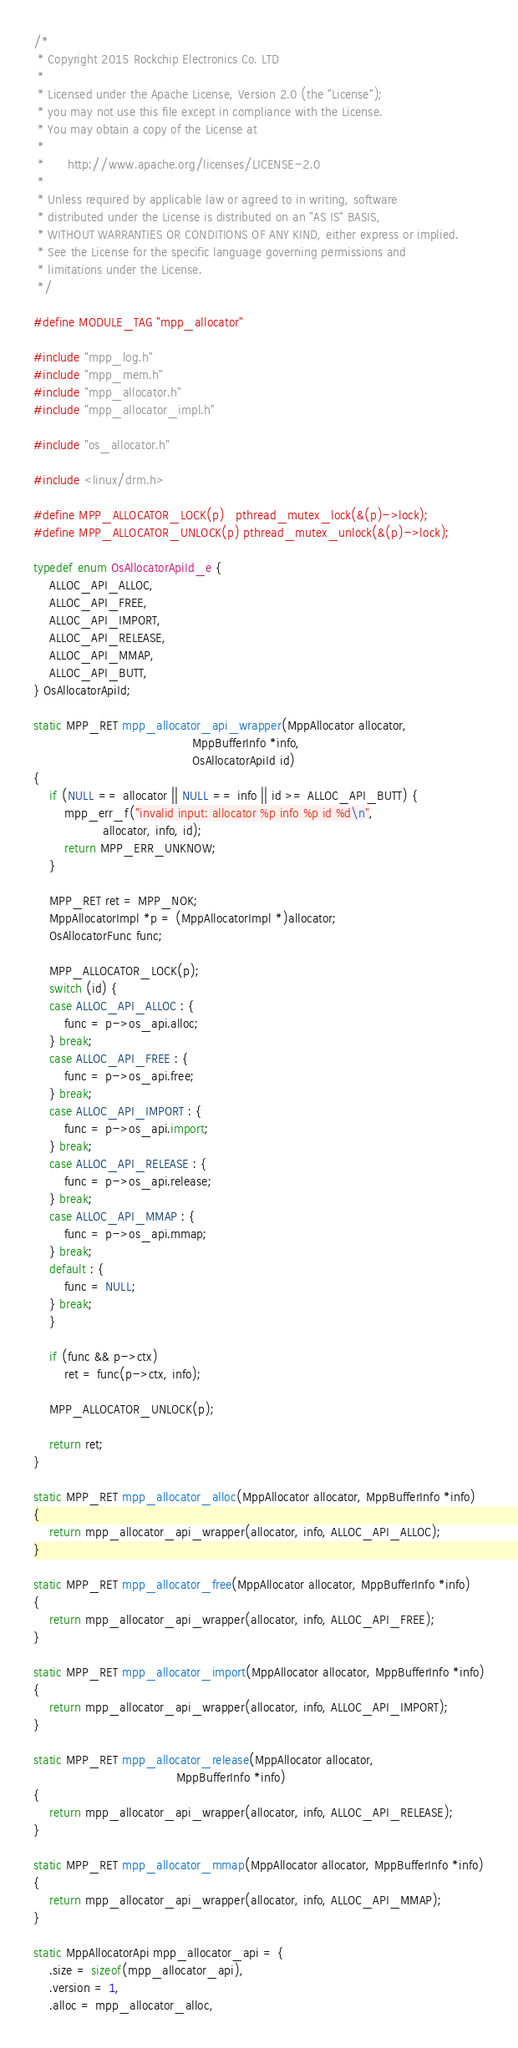<code> <loc_0><loc_0><loc_500><loc_500><_C++_>/*
 * Copyright 2015 Rockchip Electronics Co. LTD
 *
 * Licensed under the Apache License, Version 2.0 (the "License");
 * you may not use this file except in compliance with the License.
 * You may obtain a copy of the License at
 *
 *      http://www.apache.org/licenses/LICENSE-2.0
 *
 * Unless required by applicable law or agreed to in writing, software
 * distributed under the License is distributed on an "AS IS" BASIS,
 * WITHOUT WARRANTIES OR CONDITIONS OF ANY KIND, either express or implied.
 * See the License for the specific language governing permissions and
 * limitations under the License.
 */

#define MODULE_TAG "mpp_allocator"

#include "mpp_log.h"
#include "mpp_mem.h"
#include "mpp_allocator.h"
#include "mpp_allocator_impl.h"

#include "os_allocator.h"

#include <linux/drm.h>

#define MPP_ALLOCATOR_LOCK(p)   pthread_mutex_lock(&(p)->lock);
#define MPP_ALLOCATOR_UNLOCK(p) pthread_mutex_unlock(&(p)->lock);

typedef enum OsAllocatorApiId_e {
    ALLOC_API_ALLOC,
    ALLOC_API_FREE,
    ALLOC_API_IMPORT,
    ALLOC_API_RELEASE,
    ALLOC_API_MMAP,
    ALLOC_API_BUTT,
} OsAllocatorApiId;

static MPP_RET mpp_allocator_api_wrapper(MppAllocator allocator,
                                         MppBufferInfo *info,
                                         OsAllocatorApiId id)
{
    if (NULL == allocator || NULL == info || id >= ALLOC_API_BUTT) {
        mpp_err_f("invalid input: allocator %p info %p id %d\n",
                  allocator, info, id);
        return MPP_ERR_UNKNOW;
    }

    MPP_RET ret = MPP_NOK;
    MppAllocatorImpl *p = (MppAllocatorImpl *)allocator;
    OsAllocatorFunc func;

    MPP_ALLOCATOR_LOCK(p);
    switch (id) {
    case ALLOC_API_ALLOC : {
        func = p->os_api.alloc;
    } break;
    case ALLOC_API_FREE : {
        func = p->os_api.free;
    } break;
    case ALLOC_API_IMPORT : {
        func = p->os_api.import;
    } break;
    case ALLOC_API_RELEASE : {
        func = p->os_api.release;
    } break;
    case ALLOC_API_MMAP : {
        func = p->os_api.mmap;
    } break;
    default : {
        func = NULL;
    } break;
    }

    if (func && p->ctx)
        ret = func(p->ctx, info);

    MPP_ALLOCATOR_UNLOCK(p);

    return ret;
}

static MPP_RET mpp_allocator_alloc(MppAllocator allocator, MppBufferInfo *info)
{
    return mpp_allocator_api_wrapper(allocator, info, ALLOC_API_ALLOC);
}

static MPP_RET mpp_allocator_free(MppAllocator allocator, MppBufferInfo *info)
{
    return mpp_allocator_api_wrapper(allocator, info, ALLOC_API_FREE);
}

static MPP_RET mpp_allocator_import(MppAllocator allocator, MppBufferInfo *info)
{
    return mpp_allocator_api_wrapper(allocator, info, ALLOC_API_IMPORT);
}

static MPP_RET mpp_allocator_release(MppAllocator allocator,
                                     MppBufferInfo *info)
{
    return mpp_allocator_api_wrapper(allocator, info, ALLOC_API_RELEASE);
}

static MPP_RET mpp_allocator_mmap(MppAllocator allocator, MppBufferInfo *info)
{
    return mpp_allocator_api_wrapper(allocator, info, ALLOC_API_MMAP);
}

static MppAllocatorApi mpp_allocator_api = {
    .size = sizeof(mpp_allocator_api),
    .version = 1,
    .alloc = mpp_allocator_alloc,</code> 